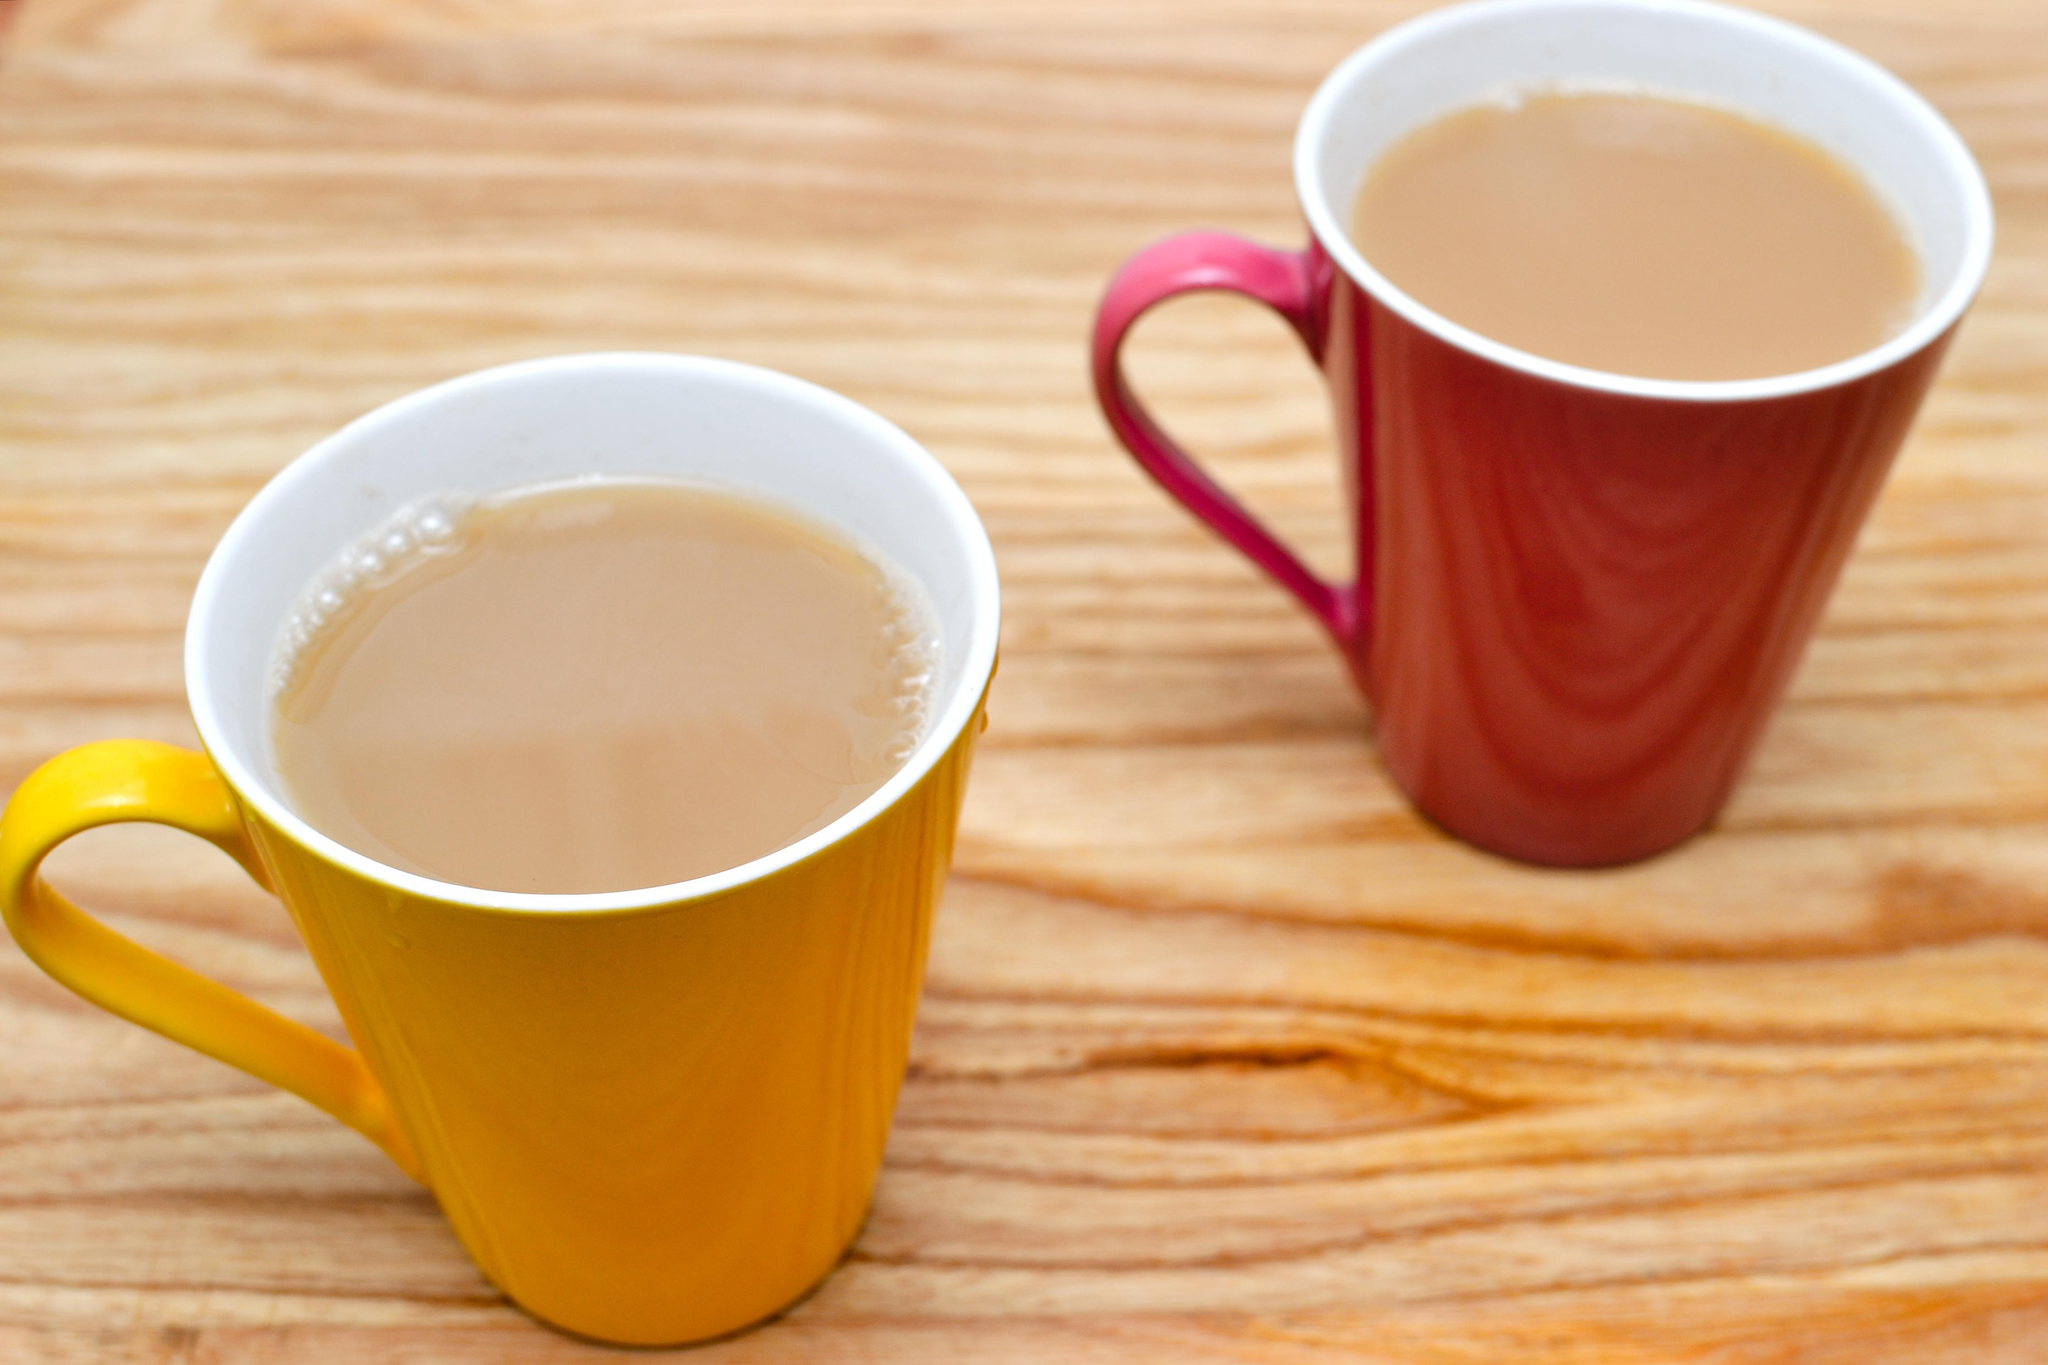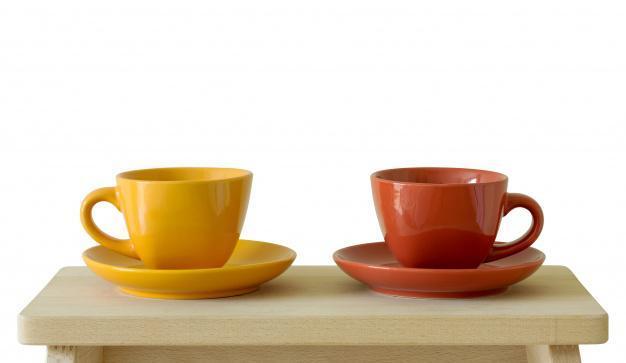The first image is the image on the left, the second image is the image on the right. Examine the images to the left and right. Is the description "Each image shows two side-by-side cups." accurate? Answer yes or no. Yes. The first image is the image on the left, the second image is the image on the right. Examine the images to the left and right. Is the description "At least one white cup sits in a white saucer." accurate? Answer yes or no. No. 